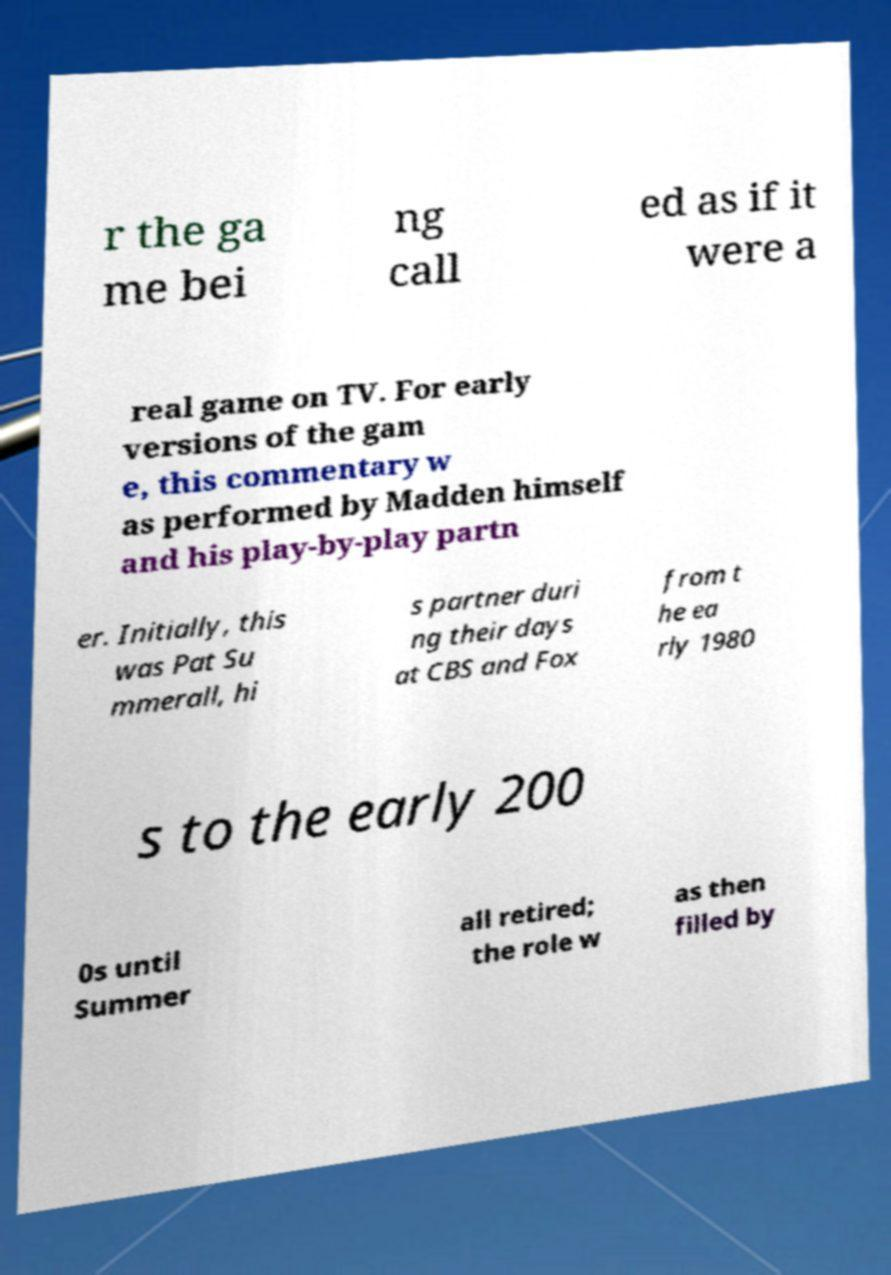Could you assist in decoding the text presented in this image and type it out clearly? r the ga me bei ng call ed as if it were a real game on TV. For early versions of the gam e, this commentary w as performed by Madden himself and his play-by-play partn er. Initially, this was Pat Su mmerall, hi s partner duri ng their days at CBS and Fox from t he ea rly 1980 s to the early 200 0s until Summer all retired; the role w as then filled by 